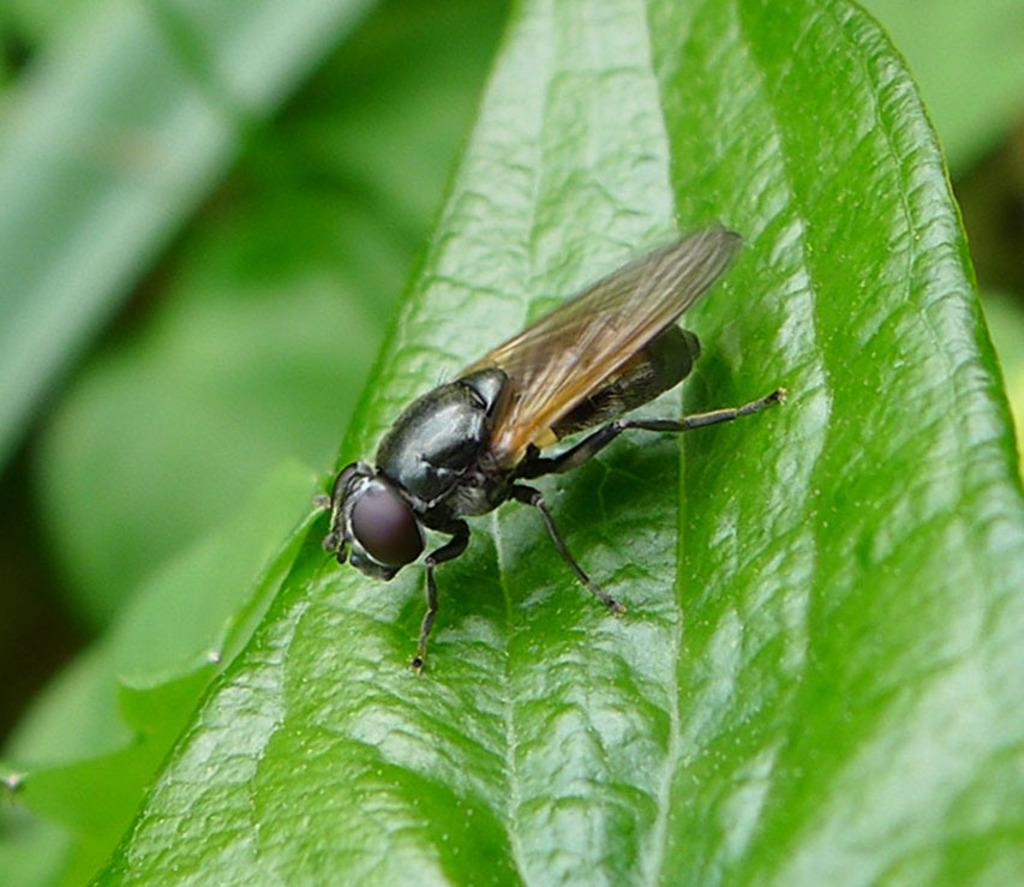What type of natural elements can be seen in the image? There are leaves in the image. What living creature is present in the image? There is an insect in the image. Can you describe the background of the image? The background of the image is blurred. What thought-provoking discovery was made in the church depicted in the image? There is no church depicted in the image, and therefore no discovery can be observed. 